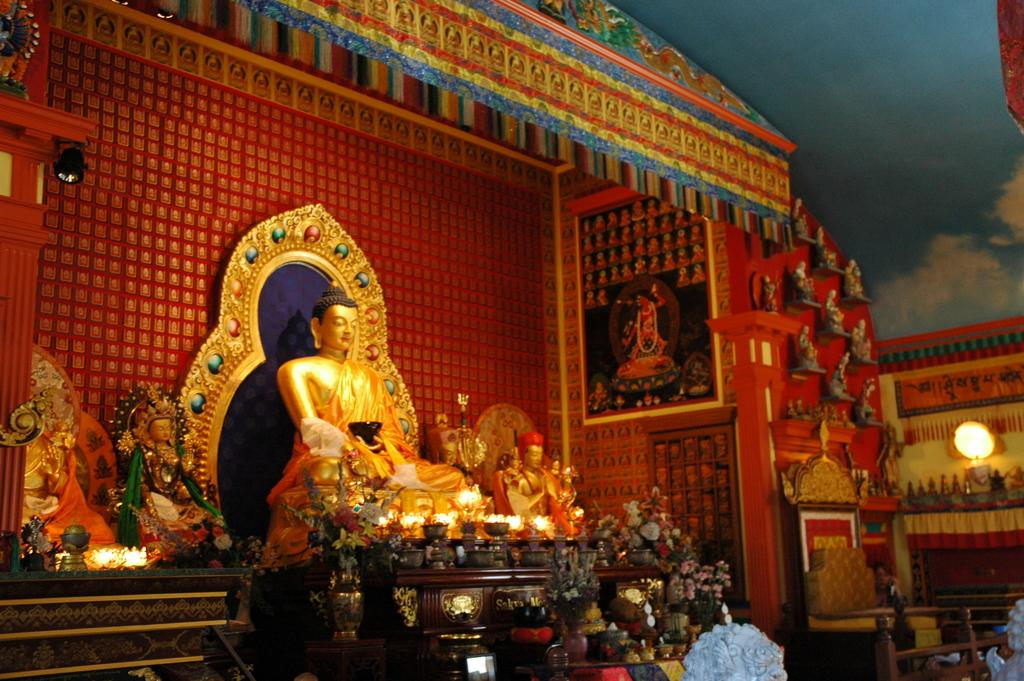What type of building is shown in the image? The image depicts the interior of a Chinese temple. What religious figure can be seen in the image? There is a statue of Lord Buddha in the image. How are the walls of the temple decorated? The walls are decorated in the image. What can be found on the walls of the temple? There are arts displayed on the walls. Can you describe a specific feature of the temple's interior? There is a wall with a light on it in the image. What type of honey is being used for treatment in the image? There is no honey or treatment present in the image; it depicts the interior of a Chinese temple. 